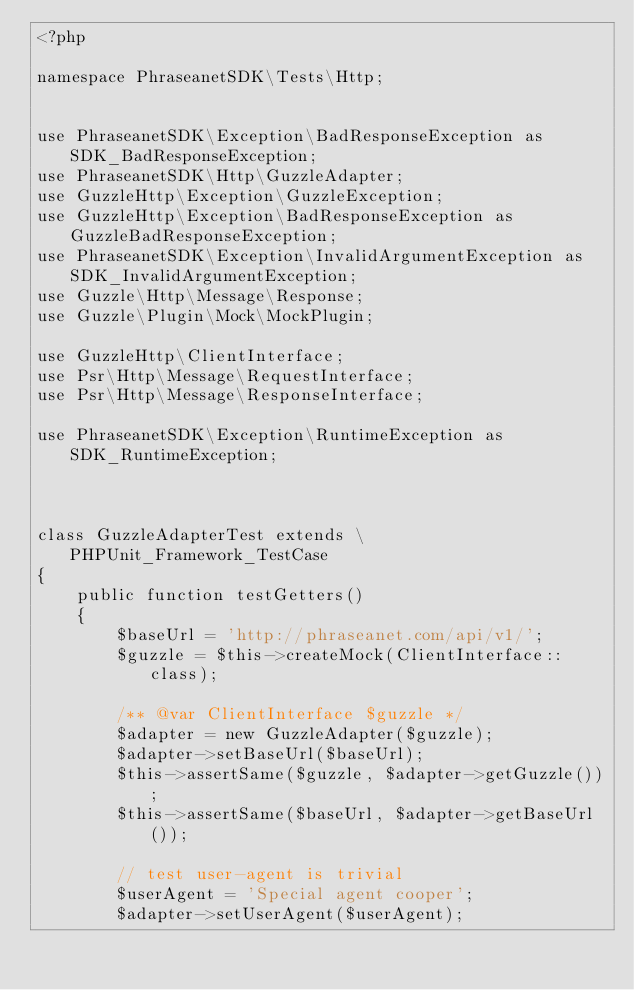<code> <loc_0><loc_0><loc_500><loc_500><_PHP_><?php

namespace PhraseanetSDK\Tests\Http;


use PhraseanetSDK\Exception\BadResponseException as SDK_BadResponseException;
use PhraseanetSDK\Http\GuzzleAdapter;
use GuzzleHttp\Exception\GuzzleException;
use GuzzleHttp\Exception\BadResponseException as GuzzleBadResponseException;
use PhraseanetSDK\Exception\InvalidArgumentException as SDK_InvalidArgumentException;
use Guzzle\Http\Message\Response;
use Guzzle\Plugin\Mock\MockPlugin;

use GuzzleHttp\ClientInterface;
use Psr\Http\Message\RequestInterface;
use Psr\Http\Message\ResponseInterface;

use PhraseanetSDK\Exception\RuntimeException as SDK_RuntimeException;



class GuzzleAdapterTest extends \PHPUnit_Framework_TestCase
{
    public function testGetters()
    {
        $baseUrl = 'http://phraseanet.com/api/v1/';
        $guzzle = $this->createMock(ClientInterface::class);

        /** @var ClientInterface $guzzle */
        $adapter = new GuzzleAdapter($guzzle);
        $adapter->setBaseUrl($baseUrl);
        $this->assertSame($guzzle, $adapter->getGuzzle());
        $this->assertSame($baseUrl, $adapter->getBaseUrl());

        // test user-agent is trivial
        $userAgent = 'Special agent cooper';
        $adapter->setUserAgent($userAgent);</code> 